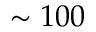Convert formula to latex. <formula><loc_0><loc_0><loc_500><loc_500>\sim 1 0 0</formula> 